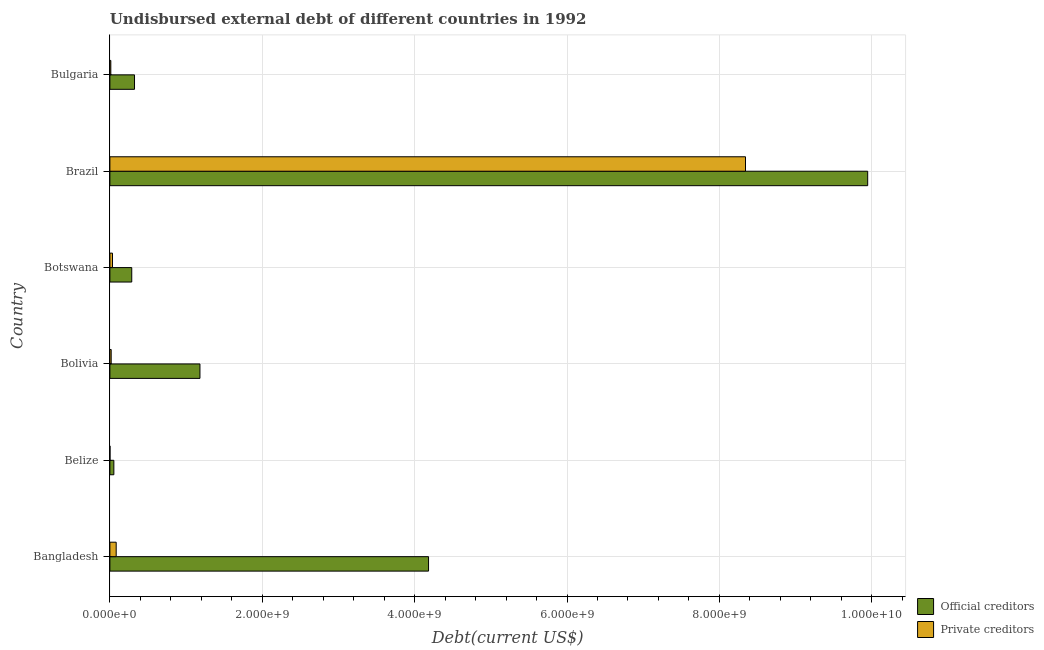How many groups of bars are there?
Make the answer very short. 6. How many bars are there on the 3rd tick from the bottom?
Make the answer very short. 2. What is the label of the 5th group of bars from the top?
Offer a terse response. Belize. What is the undisbursed external debt of private creditors in Bangladesh?
Keep it short and to the point. 8.27e+07. Across all countries, what is the maximum undisbursed external debt of official creditors?
Your answer should be very brief. 9.95e+09. Across all countries, what is the minimum undisbursed external debt of official creditors?
Offer a terse response. 5.20e+07. In which country was the undisbursed external debt of private creditors maximum?
Ensure brevity in your answer.  Brazil. In which country was the undisbursed external debt of official creditors minimum?
Provide a succinct answer. Belize. What is the total undisbursed external debt of official creditors in the graph?
Make the answer very short. 1.60e+1. What is the difference between the undisbursed external debt of private creditors in Brazil and that in Bulgaria?
Provide a succinct answer. 8.33e+09. What is the difference between the undisbursed external debt of private creditors in Bangladesh and the undisbursed external debt of official creditors in Bulgaria?
Provide a short and direct response. -2.41e+08. What is the average undisbursed external debt of private creditors per country?
Give a very brief answer. 1.42e+09. What is the difference between the undisbursed external debt of private creditors and undisbursed external debt of official creditors in Bolivia?
Keep it short and to the point. -1.17e+09. In how many countries, is the undisbursed external debt of official creditors greater than 2400000000 US$?
Offer a very short reply. 2. What is the ratio of the undisbursed external debt of official creditors in Belize to that in Bolivia?
Offer a terse response. 0.04. What is the difference between the highest and the second highest undisbursed external debt of private creditors?
Make the answer very short. 8.26e+09. What is the difference between the highest and the lowest undisbursed external debt of official creditors?
Offer a very short reply. 9.89e+09. Is the sum of the undisbursed external debt of private creditors in Bolivia and Botswana greater than the maximum undisbursed external debt of official creditors across all countries?
Give a very brief answer. No. What does the 1st bar from the top in Brazil represents?
Provide a short and direct response. Private creditors. What does the 2nd bar from the bottom in Bangladesh represents?
Give a very brief answer. Private creditors. Are all the bars in the graph horizontal?
Keep it short and to the point. Yes. Does the graph contain any zero values?
Give a very brief answer. No. How many legend labels are there?
Your answer should be compact. 2. What is the title of the graph?
Keep it short and to the point. Undisbursed external debt of different countries in 1992. Does "Forest" appear as one of the legend labels in the graph?
Your answer should be very brief. No. What is the label or title of the X-axis?
Provide a short and direct response. Debt(current US$). What is the label or title of the Y-axis?
Give a very brief answer. Country. What is the Debt(current US$) of Official creditors in Bangladesh?
Ensure brevity in your answer.  4.18e+09. What is the Debt(current US$) of Private creditors in Bangladesh?
Your answer should be compact. 8.27e+07. What is the Debt(current US$) in Official creditors in Belize?
Your answer should be very brief. 5.20e+07. What is the Debt(current US$) of Private creditors in Belize?
Offer a terse response. 1.24e+06. What is the Debt(current US$) in Official creditors in Bolivia?
Keep it short and to the point. 1.18e+09. What is the Debt(current US$) in Private creditors in Bolivia?
Keep it short and to the point. 1.69e+07. What is the Debt(current US$) of Official creditors in Botswana?
Your response must be concise. 2.87e+08. What is the Debt(current US$) of Private creditors in Botswana?
Provide a succinct answer. 3.43e+07. What is the Debt(current US$) in Official creditors in Brazil?
Make the answer very short. 9.95e+09. What is the Debt(current US$) of Private creditors in Brazil?
Ensure brevity in your answer.  8.34e+09. What is the Debt(current US$) of Official creditors in Bulgaria?
Offer a terse response. 3.23e+08. What is the Debt(current US$) in Private creditors in Bulgaria?
Provide a succinct answer. 1.22e+07. Across all countries, what is the maximum Debt(current US$) of Official creditors?
Provide a succinct answer. 9.95e+09. Across all countries, what is the maximum Debt(current US$) in Private creditors?
Offer a very short reply. 8.34e+09. Across all countries, what is the minimum Debt(current US$) of Official creditors?
Offer a terse response. 5.20e+07. Across all countries, what is the minimum Debt(current US$) in Private creditors?
Ensure brevity in your answer.  1.24e+06. What is the total Debt(current US$) in Official creditors in the graph?
Offer a terse response. 1.60e+1. What is the total Debt(current US$) of Private creditors in the graph?
Provide a succinct answer. 8.49e+09. What is the difference between the Debt(current US$) in Official creditors in Bangladesh and that in Belize?
Offer a terse response. 4.13e+09. What is the difference between the Debt(current US$) in Private creditors in Bangladesh and that in Belize?
Provide a short and direct response. 8.15e+07. What is the difference between the Debt(current US$) of Official creditors in Bangladesh and that in Bolivia?
Provide a short and direct response. 3.00e+09. What is the difference between the Debt(current US$) of Private creditors in Bangladesh and that in Bolivia?
Your response must be concise. 6.58e+07. What is the difference between the Debt(current US$) of Official creditors in Bangladesh and that in Botswana?
Keep it short and to the point. 3.90e+09. What is the difference between the Debt(current US$) of Private creditors in Bangladesh and that in Botswana?
Keep it short and to the point. 4.85e+07. What is the difference between the Debt(current US$) in Official creditors in Bangladesh and that in Brazil?
Your response must be concise. -5.76e+09. What is the difference between the Debt(current US$) of Private creditors in Bangladesh and that in Brazil?
Offer a very short reply. -8.26e+09. What is the difference between the Debt(current US$) of Official creditors in Bangladesh and that in Bulgaria?
Give a very brief answer. 3.86e+09. What is the difference between the Debt(current US$) in Private creditors in Bangladesh and that in Bulgaria?
Give a very brief answer. 7.06e+07. What is the difference between the Debt(current US$) of Official creditors in Belize and that in Bolivia?
Give a very brief answer. -1.13e+09. What is the difference between the Debt(current US$) of Private creditors in Belize and that in Bolivia?
Make the answer very short. -1.57e+07. What is the difference between the Debt(current US$) in Official creditors in Belize and that in Botswana?
Provide a succinct answer. -2.35e+08. What is the difference between the Debt(current US$) of Private creditors in Belize and that in Botswana?
Your response must be concise. -3.30e+07. What is the difference between the Debt(current US$) in Official creditors in Belize and that in Brazil?
Offer a very short reply. -9.89e+09. What is the difference between the Debt(current US$) of Private creditors in Belize and that in Brazil?
Provide a short and direct response. -8.34e+09. What is the difference between the Debt(current US$) in Official creditors in Belize and that in Bulgaria?
Give a very brief answer. -2.71e+08. What is the difference between the Debt(current US$) of Private creditors in Belize and that in Bulgaria?
Provide a short and direct response. -1.09e+07. What is the difference between the Debt(current US$) of Official creditors in Bolivia and that in Botswana?
Your answer should be compact. 8.95e+08. What is the difference between the Debt(current US$) of Private creditors in Bolivia and that in Botswana?
Provide a short and direct response. -1.73e+07. What is the difference between the Debt(current US$) of Official creditors in Bolivia and that in Brazil?
Your response must be concise. -8.76e+09. What is the difference between the Debt(current US$) in Private creditors in Bolivia and that in Brazil?
Offer a terse response. -8.33e+09. What is the difference between the Debt(current US$) in Official creditors in Bolivia and that in Bulgaria?
Offer a very short reply. 8.59e+08. What is the difference between the Debt(current US$) of Private creditors in Bolivia and that in Bulgaria?
Your answer should be compact. 4.78e+06. What is the difference between the Debt(current US$) of Official creditors in Botswana and that in Brazil?
Provide a succinct answer. -9.66e+09. What is the difference between the Debt(current US$) of Private creditors in Botswana and that in Brazil?
Keep it short and to the point. -8.31e+09. What is the difference between the Debt(current US$) of Official creditors in Botswana and that in Bulgaria?
Give a very brief answer. -3.62e+07. What is the difference between the Debt(current US$) of Private creditors in Botswana and that in Bulgaria?
Give a very brief answer. 2.21e+07. What is the difference between the Debt(current US$) of Official creditors in Brazil and that in Bulgaria?
Your response must be concise. 9.62e+09. What is the difference between the Debt(current US$) in Private creditors in Brazil and that in Bulgaria?
Your answer should be very brief. 8.33e+09. What is the difference between the Debt(current US$) of Official creditors in Bangladesh and the Debt(current US$) of Private creditors in Belize?
Your response must be concise. 4.18e+09. What is the difference between the Debt(current US$) of Official creditors in Bangladesh and the Debt(current US$) of Private creditors in Bolivia?
Your answer should be compact. 4.17e+09. What is the difference between the Debt(current US$) in Official creditors in Bangladesh and the Debt(current US$) in Private creditors in Botswana?
Your answer should be compact. 4.15e+09. What is the difference between the Debt(current US$) of Official creditors in Bangladesh and the Debt(current US$) of Private creditors in Brazil?
Your answer should be compact. -4.16e+09. What is the difference between the Debt(current US$) of Official creditors in Bangladesh and the Debt(current US$) of Private creditors in Bulgaria?
Your response must be concise. 4.17e+09. What is the difference between the Debt(current US$) of Official creditors in Belize and the Debt(current US$) of Private creditors in Bolivia?
Your response must be concise. 3.51e+07. What is the difference between the Debt(current US$) of Official creditors in Belize and the Debt(current US$) of Private creditors in Botswana?
Keep it short and to the point. 1.78e+07. What is the difference between the Debt(current US$) in Official creditors in Belize and the Debt(current US$) in Private creditors in Brazil?
Provide a succinct answer. -8.29e+09. What is the difference between the Debt(current US$) of Official creditors in Belize and the Debt(current US$) of Private creditors in Bulgaria?
Keep it short and to the point. 3.99e+07. What is the difference between the Debt(current US$) in Official creditors in Bolivia and the Debt(current US$) in Private creditors in Botswana?
Offer a terse response. 1.15e+09. What is the difference between the Debt(current US$) of Official creditors in Bolivia and the Debt(current US$) of Private creditors in Brazil?
Offer a very short reply. -7.16e+09. What is the difference between the Debt(current US$) in Official creditors in Bolivia and the Debt(current US$) in Private creditors in Bulgaria?
Keep it short and to the point. 1.17e+09. What is the difference between the Debt(current US$) in Official creditors in Botswana and the Debt(current US$) in Private creditors in Brazil?
Offer a very short reply. -8.06e+09. What is the difference between the Debt(current US$) in Official creditors in Botswana and the Debt(current US$) in Private creditors in Bulgaria?
Offer a very short reply. 2.75e+08. What is the difference between the Debt(current US$) in Official creditors in Brazil and the Debt(current US$) in Private creditors in Bulgaria?
Offer a very short reply. 9.93e+09. What is the average Debt(current US$) in Official creditors per country?
Ensure brevity in your answer.  2.66e+09. What is the average Debt(current US$) in Private creditors per country?
Your answer should be very brief. 1.42e+09. What is the difference between the Debt(current US$) of Official creditors and Debt(current US$) of Private creditors in Bangladesh?
Keep it short and to the point. 4.10e+09. What is the difference between the Debt(current US$) in Official creditors and Debt(current US$) in Private creditors in Belize?
Your answer should be compact. 5.08e+07. What is the difference between the Debt(current US$) of Official creditors and Debt(current US$) of Private creditors in Bolivia?
Offer a very short reply. 1.17e+09. What is the difference between the Debt(current US$) of Official creditors and Debt(current US$) of Private creditors in Botswana?
Give a very brief answer. 2.53e+08. What is the difference between the Debt(current US$) in Official creditors and Debt(current US$) in Private creditors in Brazil?
Keep it short and to the point. 1.60e+09. What is the difference between the Debt(current US$) in Official creditors and Debt(current US$) in Private creditors in Bulgaria?
Your answer should be compact. 3.11e+08. What is the ratio of the Debt(current US$) of Official creditors in Bangladesh to that in Belize?
Your answer should be very brief. 80.39. What is the ratio of the Debt(current US$) in Private creditors in Bangladesh to that in Belize?
Provide a short and direct response. 66.71. What is the ratio of the Debt(current US$) in Official creditors in Bangladesh to that in Bolivia?
Offer a very short reply. 3.54. What is the ratio of the Debt(current US$) of Private creditors in Bangladesh to that in Bolivia?
Give a very brief answer. 4.88. What is the ratio of the Debt(current US$) in Official creditors in Bangladesh to that in Botswana?
Give a very brief answer. 14.57. What is the ratio of the Debt(current US$) in Private creditors in Bangladesh to that in Botswana?
Give a very brief answer. 2.41. What is the ratio of the Debt(current US$) of Official creditors in Bangladesh to that in Brazil?
Your answer should be very brief. 0.42. What is the ratio of the Debt(current US$) in Private creditors in Bangladesh to that in Brazil?
Provide a succinct answer. 0.01. What is the ratio of the Debt(current US$) in Official creditors in Bangladesh to that in Bulgaria?
Offer a very short reply. 12.94. What is the ratio of the Debt(current US$) of Private creditors in Bangladesh to that in Bulgaria?
Your answer should be very brief. 6.8. What is the ratio of the Debt(current US$) in Official creditors in Belize to that in Bolivia?
Provide a succinct answer. 0.04. What is the ratio of the Debt(current US$) of Private creditors in Belize to that in Bolivia?
Provide a succinct answer. 0.07. What is the ratio of the Debt(current US$) in Official creditors in Belize to that in Botswana?
Offer a very short reply. 0.18. What is the ratio of the Debt(current US$) of Private creditors in Belize to that in Botswana?
Your answer should be compact. 0.04. What is the ratio of the Debt(current US$) in Official creditors in Belize to that in Brazil?
Ensure brevity in your answer.  0.01. What is the ratio of the Debt(current US$) of Private creditors in Belize to that in Brazil?
Your response must be concise. 0. What is the ratio of the Debt(current US$) in Official creditors in Belize to that in Bulgaria?
Offer a very short reply. 0.16. What is the ratio of the Debt(current US$) in Private creditors in Belize to that in Bulgaria?
Your answer should be very brief. 0.1. What is the ratio of the Debt(current US$) of Official creditors in Bolivia to that in Botswana?
Your answer should be very brief. 4.12. What is the ratio of the Debt(current US$) of Private creditors in Bolivia to that in Botswana?
Offer a very short reply. 0.49. What is the ratio of the Debt(current US$) in Official creditors in Bolivia to that in Brazil?
Your answer should be very brief. 0.12. What is the ratio of the Debt(current US$) in Private creditors in Bolivia to that in Brazil?
Provide a succinct answer. 0. What is the ratio of the Debt(current US$) of Official creditors in Bolivia to that in Bulgaria?
Your response must be concise. 3.66. What is the ratio of the Debt(current US$) in Private creditors in Bolivia to that in Bulgaria?
Offer a terse response. 1.39. What is the ratio of the Debt(current US$) of Official creditors in Botswana to that in Brazil?
Your answer should be compact. 0.03. What is the ratio of the Debt(current US$) of Private creditors in Botswana to that in Brazil?
Give a very brief answer. 0. What is the ratio of the Debt(current US$) in Official creditors in Botswana to that in Bulgaria?
Make the answer very short. 0.89. What is the ratio of the Debt(current US$) in Private creditors in Botswana to that in Bulgaria?
Give a very brief answer. 2.82. What is the ratio of the Debt(current US$) of Official creditors in Brazil to that in Bulgaria?
Offer a terse response. 30.77. What is the ratio of the Debt(current US$) in Private creditors in Brazil to that in Bulgaria?
Provide a succinct answer. 686.16. What is the difference between the highest and the second highest Debt(current US$) of Official creditors?
Ensure brevity in your answer.  5.76e+09. What is the difference between the highest and the second highest Debt(current US$) in Private creditors?
Ensure brevity in your answer.  8.26e+09. What is the difference between the highest and the lowest Debt(current US$) in Official creditors?
Give a very brief answer. 9.89e+09. What is the difference between the highest and the lowest Debt(current US$) of Private creditors?
Offer a very short reply. 8.34e+09. 